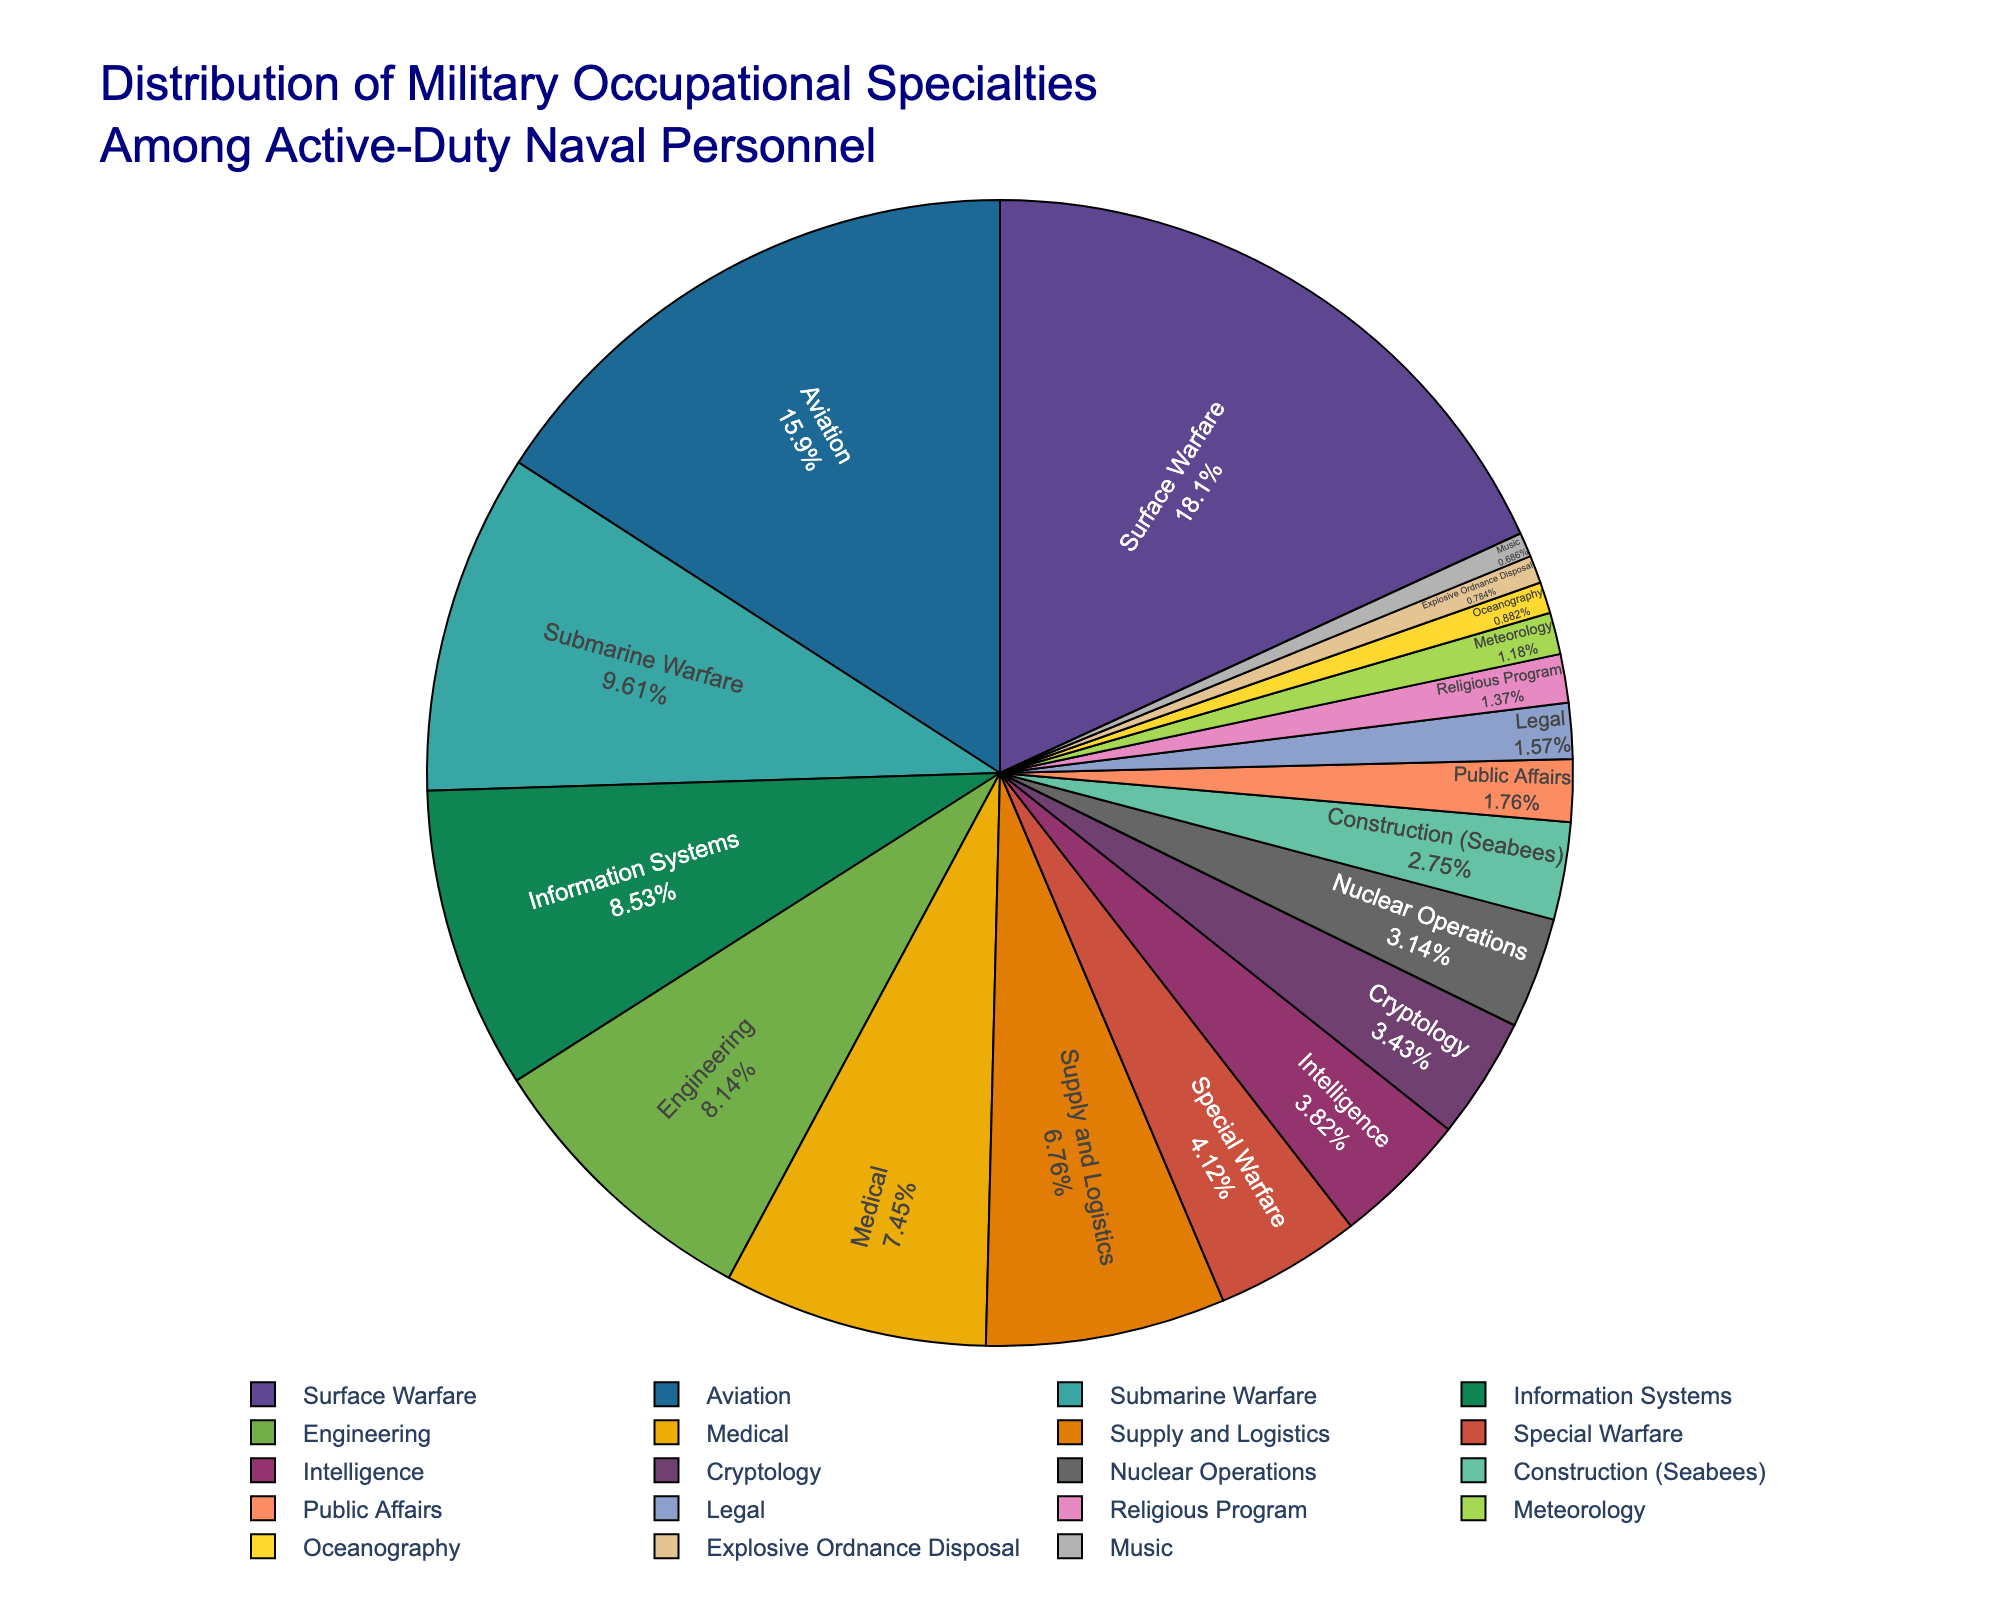What percentage of active-duty naval personnel are involved in Surface Warfare? To find the percentage of active-duty naval personnel involved in Surface Warfare, refer to the segment labeled "Surface Warfare".
Answer: 18.5% Compare the percentages of active-duty naval personnel in Aviation and Engineering. Look at the segments labeled "Aviation" and "Engineering". Aviation has 16.2% and Engineering has 8.3%, so Aviation has a higher percentage.
Answer: Aviation has a higher percentage What is the combined percentage of personnel in Information Systems and Medical specialties? Sum the percentages for "Information Systems" (8.7%) and "Medical" (7.6%). The combined percentage is 8.7% + 7.6% = 16.3%.
Answer: 16.3% Which specialty has the smallest percentage of active-duty naval personnel, and what is that percentage? Identify the smallest segment in the pie chart. The "Music" specialty is the smallest with 0.7%.
Answer: Music, 0.7% How does the percentage of personnel in Submarine Warfare compare to that in Supply and Logistics? Look at the segments for "Submarine Warfare" (9.8%) and "Supply and Logistics" (6.9%). Submarine Warfare has a higher percentage.
Answer: Submarine Warfare has a higher percentage What is the difference in the percentages of personnel between Special Warfare and Cryptology? Subtract the percentage of "Cryptology" (3.5%) from "Special Warfare" (4.2%). The difference is 4.2% - 3.5% = 0.7%.
Answer: 0.7% What percentage of active-duty naval personnel are in Cryptology and Construction specialties combined? Sum the percentages for "Cryptology" (3.5%) and "Construction (Seabees)" (2.8%). The combined percentage is 3.5% + 2.8% = 6.3%.
Answer: 6.3% Which specialty falls in the middle when the percentages are arranged in ascending order? Order the percentages from smallest to largest and identify the middle value. The middle specialty after sorting is "Supply and Logistics" with 6.9%.
Answer: Supply and Logistics What is the total percentage of personnel in the three least common specialties? Sum the percentages for the three smallest segments: "Music" (0.7%), "Explosive Ordnance Disposal" (0.8%), and "Oceanography" (0.9%). The total is 0.7% + 0.8% + 0.9% = 2.4%.
Answer: 2.4% Is the percentage of active-duty naval personnel in Legal greater than or less than in Public Affairs? Compare the segments labeled "Legal" (1.6%) and "Public Affairs" (1.8%). Public Affairs has a higher percentage.
Answer: Less than 